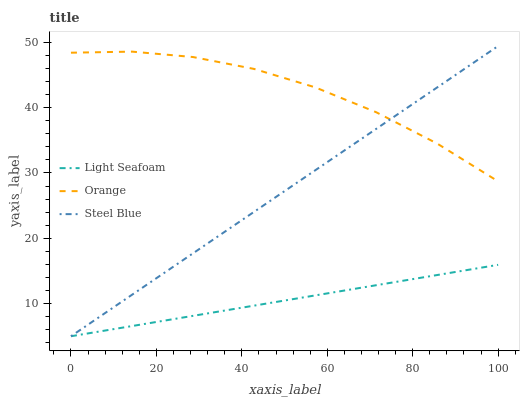Does Light Seafoam have the minimum area under the curve?
Answer yes or no. Yes. Does Orange have the maximum area under the curve?
Answer yes or no. Yes. Does Steel Blue have the minimum area under the curve?
Answer yes or no. No. Does Steel Blue have the maximum area under the curve?
Answer yes or no. No. Is Light Seafoam the smoothest?
Answer yes or no. Yes. Is Orange the roughest?
Answer yes or no. Yes. Is Steel Blue the smoothest?
Answer yes or no. No. Is Steel Blue the roughest?
Answer yes or no. No. Does Light Seafoam have the lowest value?
Answer yes or no. Yes. Does Steel Blue have the highest value?
Answer yes or no. Yes. Does Light Seafoam have the highest value?
Answer yes or no. No. Is Light Seafoam less than Orange?
Answer yes or no. Yes. Is Orange greater than Light Seafoam?
Answer yes or no. Yes. Does Light Seafoam intersect Steel Blue?
Answer yes or no. Yes. Is Light Seafoam less than Steel Blue?
Answer yes or no. No. Is Light Seafoam greater than Steel Blue?
Answer yes or no. No. Does Light Seafoam intersect Orange?
Answer yes or no. No. 